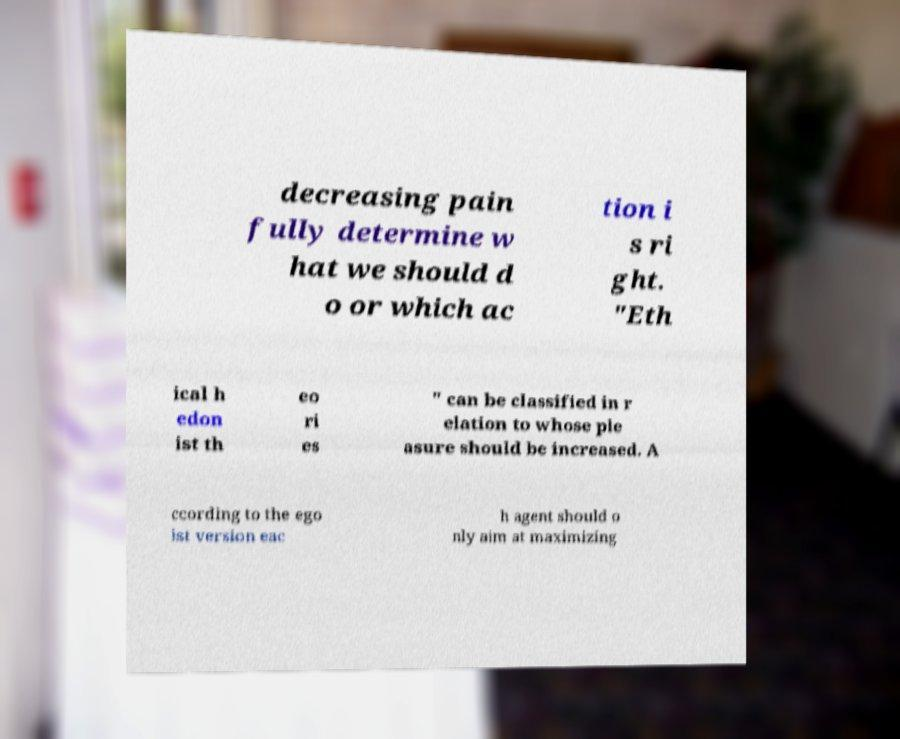What messages or text are displayed in this image? I need them in a readable, typed format. decreasing pain fully determine w hat we should d o or which ac tion i s ri ght. "Eth ical h edon ist th eo ri es " can be classified in r elation to whose ple asure should be increased. A ccording to the ego ist version eac h agent should o nly aim at maximizing 